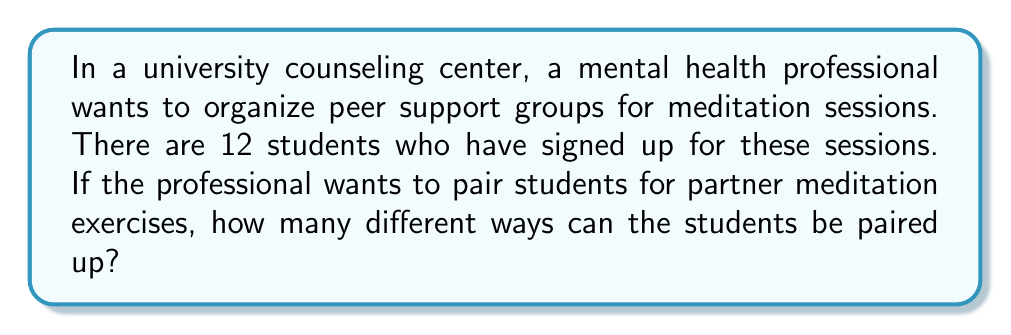Provide a solution to this math problem. Let's approach this step-by-step:

1) We need to pair all 12 students, which means we're creating 6 pairs (12 ÷ 2 = 6).

2) This is a perfect scenario for using the concept of perfect matching in a complete graph with 12 vertices.

3) The formula for the number of perfect matchings in a complete graph with $n$ vertices (where $n$ is even) is:

   $$(n-1)!! = (n-1) \times (n-3) \times (n-5) \times ... \times 3 \times 1$$

   Where $!!$ denotes the double factorial.

4) In our case, $n = 12$, so we need to calculate:

   $$11!! = 11 \times 9 \times 7 \times 5 \times 3 \times 1$$

5) Let's multiply these numbers:
   
   $$11 \times 9 = 99$$
   $$99 \times 7 = 693$$
   $$693 \times 5 = 3,465$$
   $$3,465 \times 3 = 10,395$$
   $$10,395 \times 1 = 10,395$$

6) Therefore, the number of ways to pair 12 students is 10,395.
Answer: 10,395 